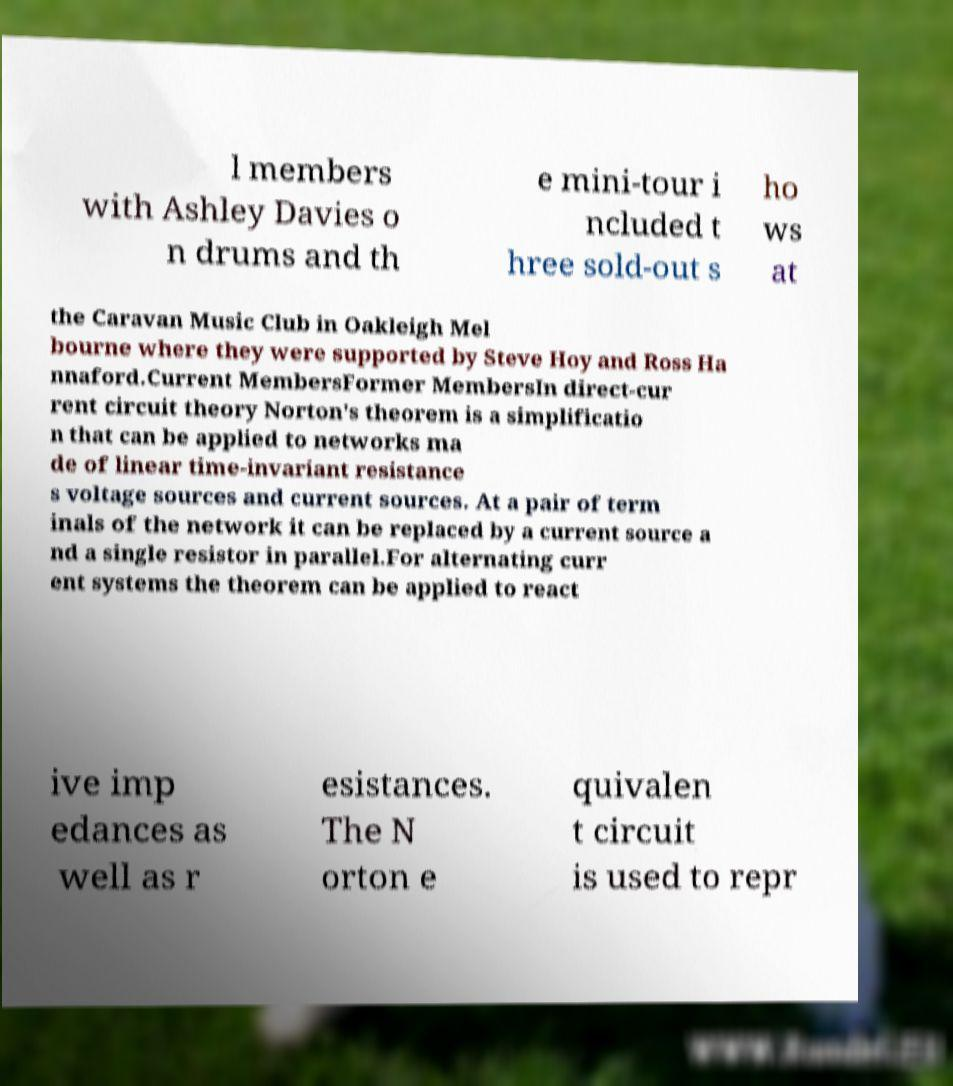For documentation purposes, I need the text within this image transcribed. Could you provide that? l members with Ashley Davies o n drums and th e mini-tour i ncluded t hree sold-out s ho ws at the Caravan Music Club in Oakleigh Mel bourne where they were supported by Steve Hoy and Ross Ha nnaford.Current MembersFormer MembersIn direct-cur rent circuit theory Norton's theorem is a simplificatio n that can be applied to networks ma de of linear time-invariant resistance s voltage sources and current sources. At a pair of term inals of the network it can be replaced by a current source a nd a single resistor in parallel.For alternating curr ent systems the theorem can be applied to react ive imp edances as well as r esistances. The N orton e quivalen t circuit is used to repr 